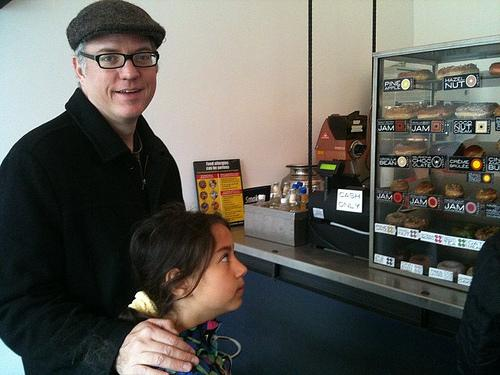How does the sign on the counter communicate the business's payment policy? The sign indicates that the business is cash only. Provide a short description of the girl in the image. A little girl with black hair and a yellow scrunchie, looking at the food display. What is the relationship between the man and the girl in the image? The man has his hand on the girl's shoulder, suggesting they have a close relationship. List three objects that can be found on the counter. A cash register, a glass jar, and a large silver vase. Identify a type of pastry in the display case. There are doughnuts in the display case. Describe the girl's hairstyle and its accessory. The girl has black hair tied in a ponytail with a yellow scrunchie. What kind of eyewear is the man wearing, and where are the glasses positioned? The man is wearing dark glasses that are positioned on his face. What emotion can be seen on the man's face? The man has a smile on his face. What accessory is the man wearing on his head? The man is wearing a dark grey hat. Comment on the type of items being sold in the store. The store sells pastries like donuts. I wonder if the woman in the red dress is waiting in line. There is no woman in a red dress in the image. Notice the poster advertising a sale on the wall. There is no poster advertising a sale in the image. Identify the balloons floating near the ceiling. There are no balloons in the image. Find the cat hiding behind the cash register. There is no cat in the image. Is there a laptop on the countertop being used for transactions? There is no laptop in the image. Can you spot the green bicycle leaning against the wall? There is no green bicycle in the image. 